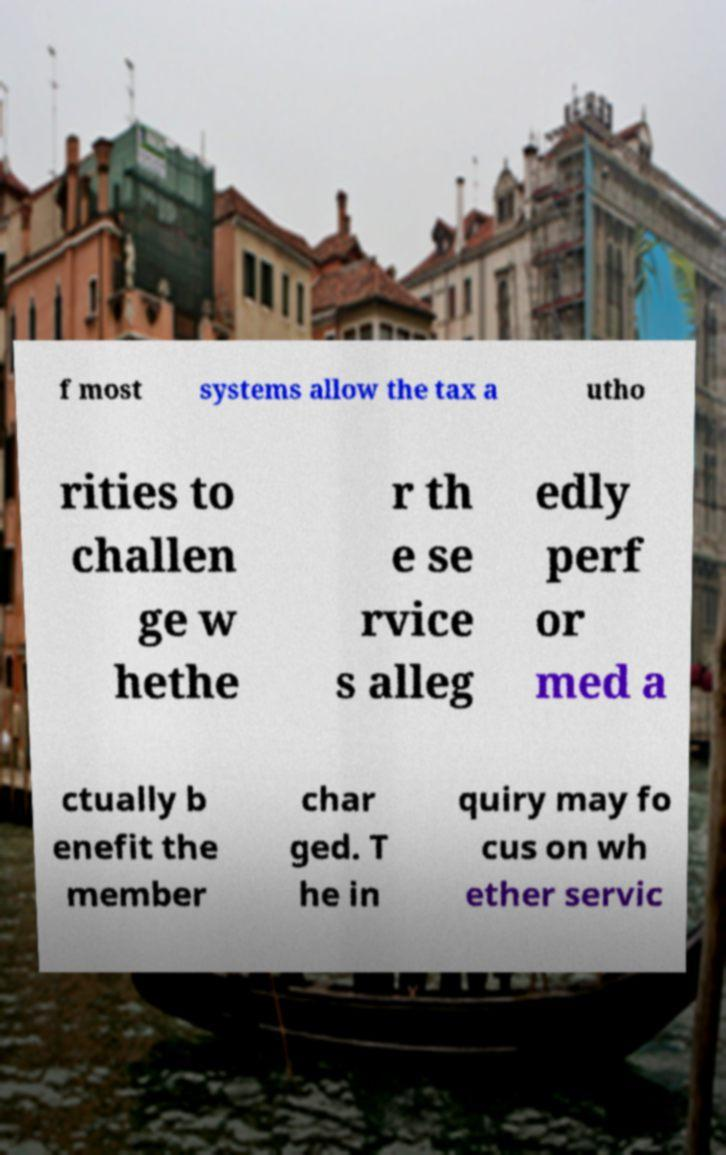For documentation purposes, I need the text within this image transcribed. Could you provide that? f most systems allow the tax a utho rities to challen ge w hethe r th e se rvice s alleg edly perf or med a ctually b enefit the member char ged. T he in quiry may fo cus on wh ether servic 